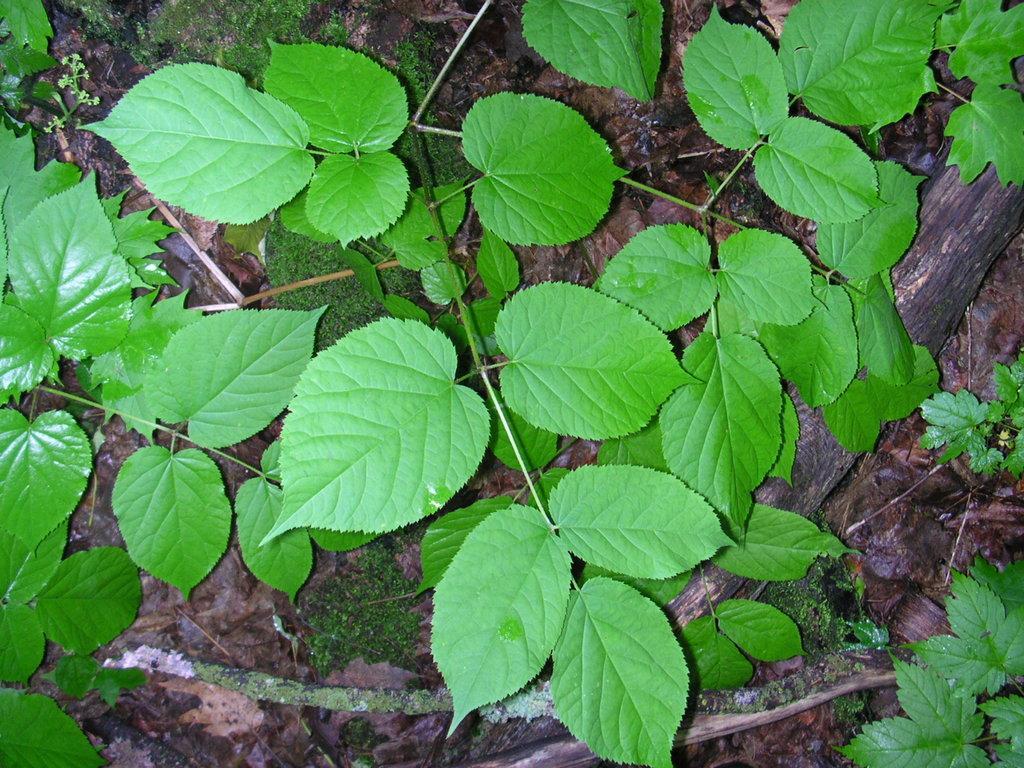Describe this image in one or two sentences. In the foreground of this image, there are plants and a wooden pole like an object on the ground. 